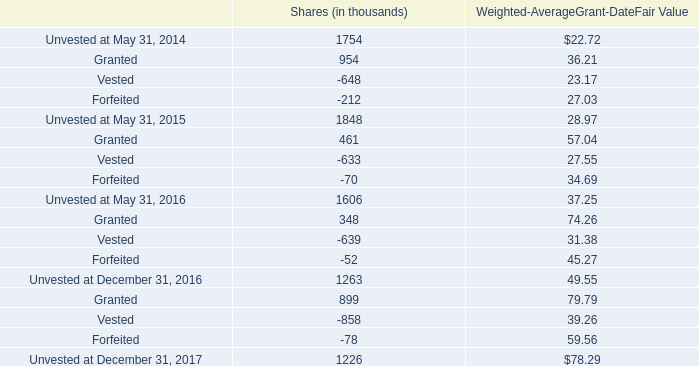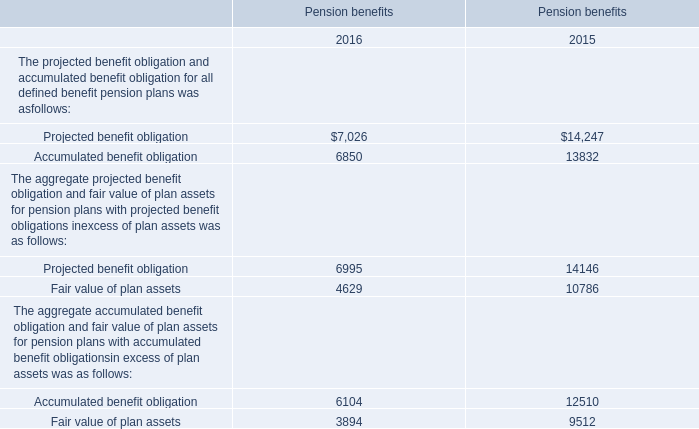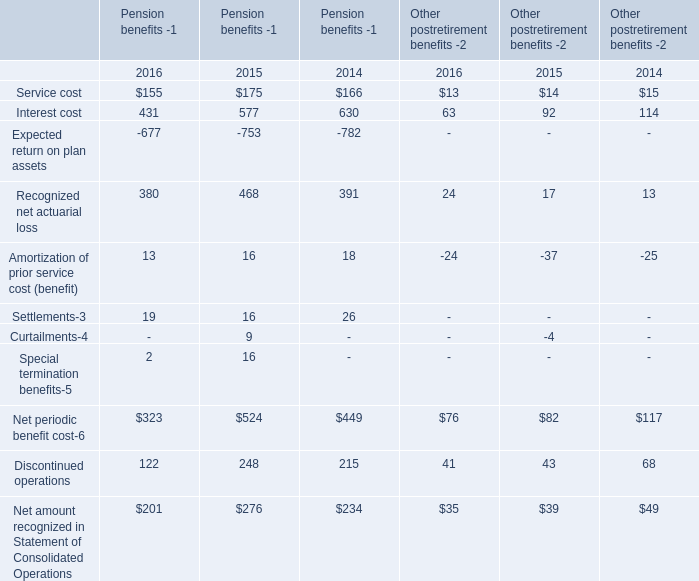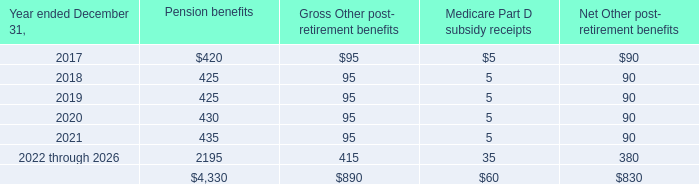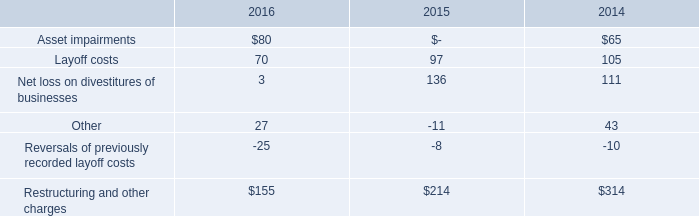What was the total amount of the Amortization of prior service cost (benefit) in the years where Recognized net actuarial loss greater than 0? 
Computations: (((((13 + 16) + 18) - 24) - 37) - 25)
Answer: -39.0. 